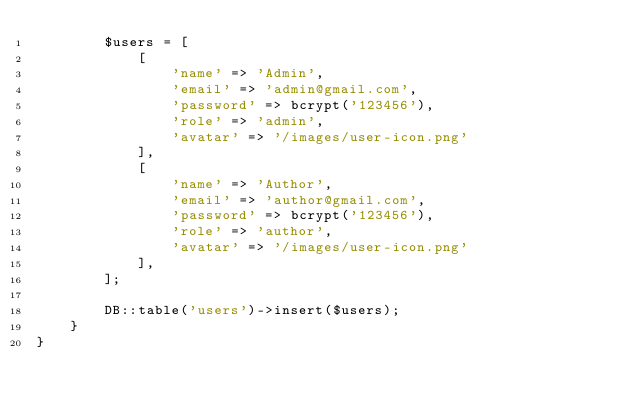Convert code to text. <code><loc_0><loc_0><loc_500><loc_500><_PHP_>        $users = [
            [
                'name' => 'Admin',
                'email' => 'admin@gmail.com',
                'password' => bcrypt('123456'),
                'role' => 'admin',
                'avatar' => '/images/user-icon.png'
            ],
            [
                'name' => 'Author',
                'email' => 'author@gmail.com',
                'password' => bcrypt('123456'),
                'role' => 'author',
                'avatar' => '/images/user-icon.png'
            ],
        ];

        DB::table('users')->insert($users);
    }
}
</code> 